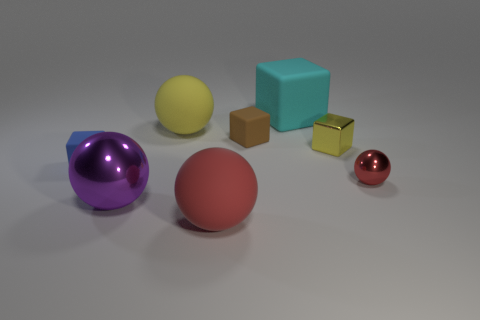Subtract 2 blocks. How many blocks are left? 2 Subtract all big yellow matte spheres. How many spheres are left? 3 Subtract all purple cylinders. How many cyan cubes are left? 1 Subtract all red spheres. How many spheres are left? 2 Subtract 0 green cylinders. How many objects are left? 8 Subtract all green cubes. Subtract all red balls. How many cubes are left? 4 Subtract all brown rubber things. Subtract all red metal objects. How many objects are left? 6 Add 7 red rubber objects. How many red rubber objects are left? 8 Add 3 purple metal things. How many purple metal things exist? 4 Add 2 blue matte things. How many objects exist? 10 